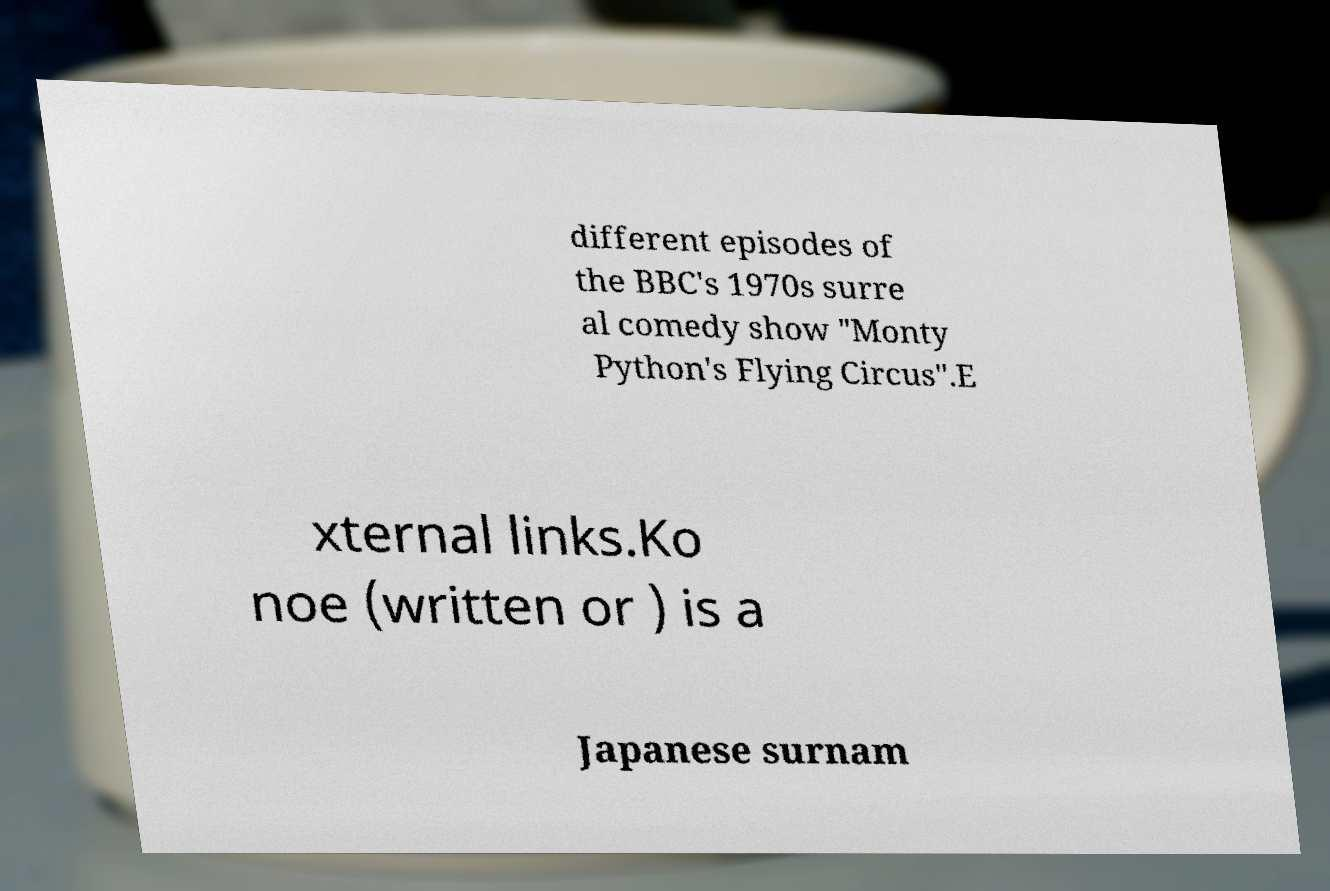There's text embedded in this image that I need extracted. Can you transcribe it verbatim? different episodes of the BBC's 1970s surre al comedy show "Monty Python's Flying Circus".E xternal links.Ko noe (written or ) is a Japanese surnam 